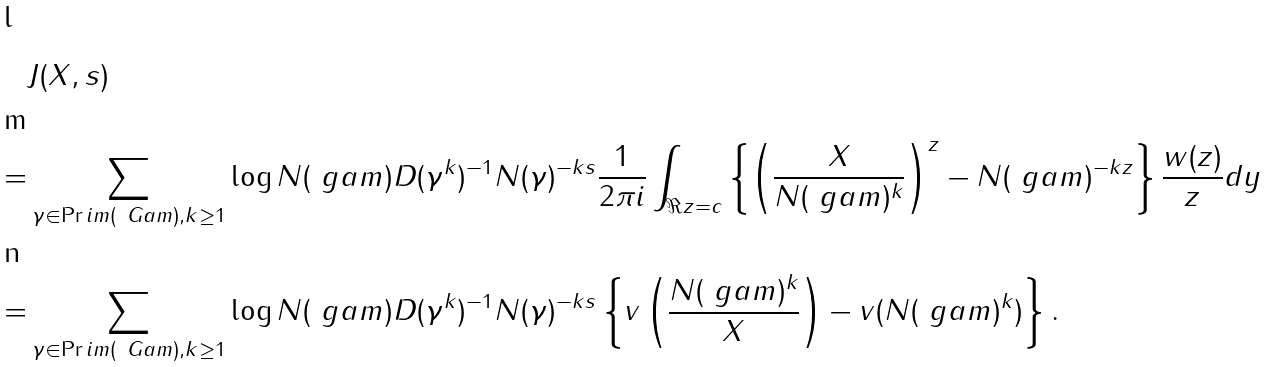<formula> <loc_0><loc_0><loc_500><loc_500>& J ( X , s ) \\ = & \sum _ { \gamma \in \Pr i m ( \ G a m ) , k \geq 1 } \log { N ( \ g a m ) } D ( \gamma ^ { k } ) ^ { - 1 } N ( \gamma ) ^ { - k s } \frac { 1 } { 2 \pi i } \int _ { \Re { z } = c } \left \{ \left ( \frac { X } { N ( \ g a m ) ^ { k } } \right ) ^ { z } - N ( \ g a m ) ^ { - k z } \right \} \frac { w ( z ) } { z } d y \\ = & \sum _ { \gamma \in \Pr i m ( \ G a m ) , k \geq 1 } \log { N ( \ g a m ) } D ( \gamma ^ { k } ) ^ { - 1 } N ( \gamma ) ^ { - k s } \left \{ v \left ( \frac { N ( \ g a m ) ^ { k } } { X } \right ) - v ( N ( \ g a m ) ^ { k } ) \right \} .</formula> 